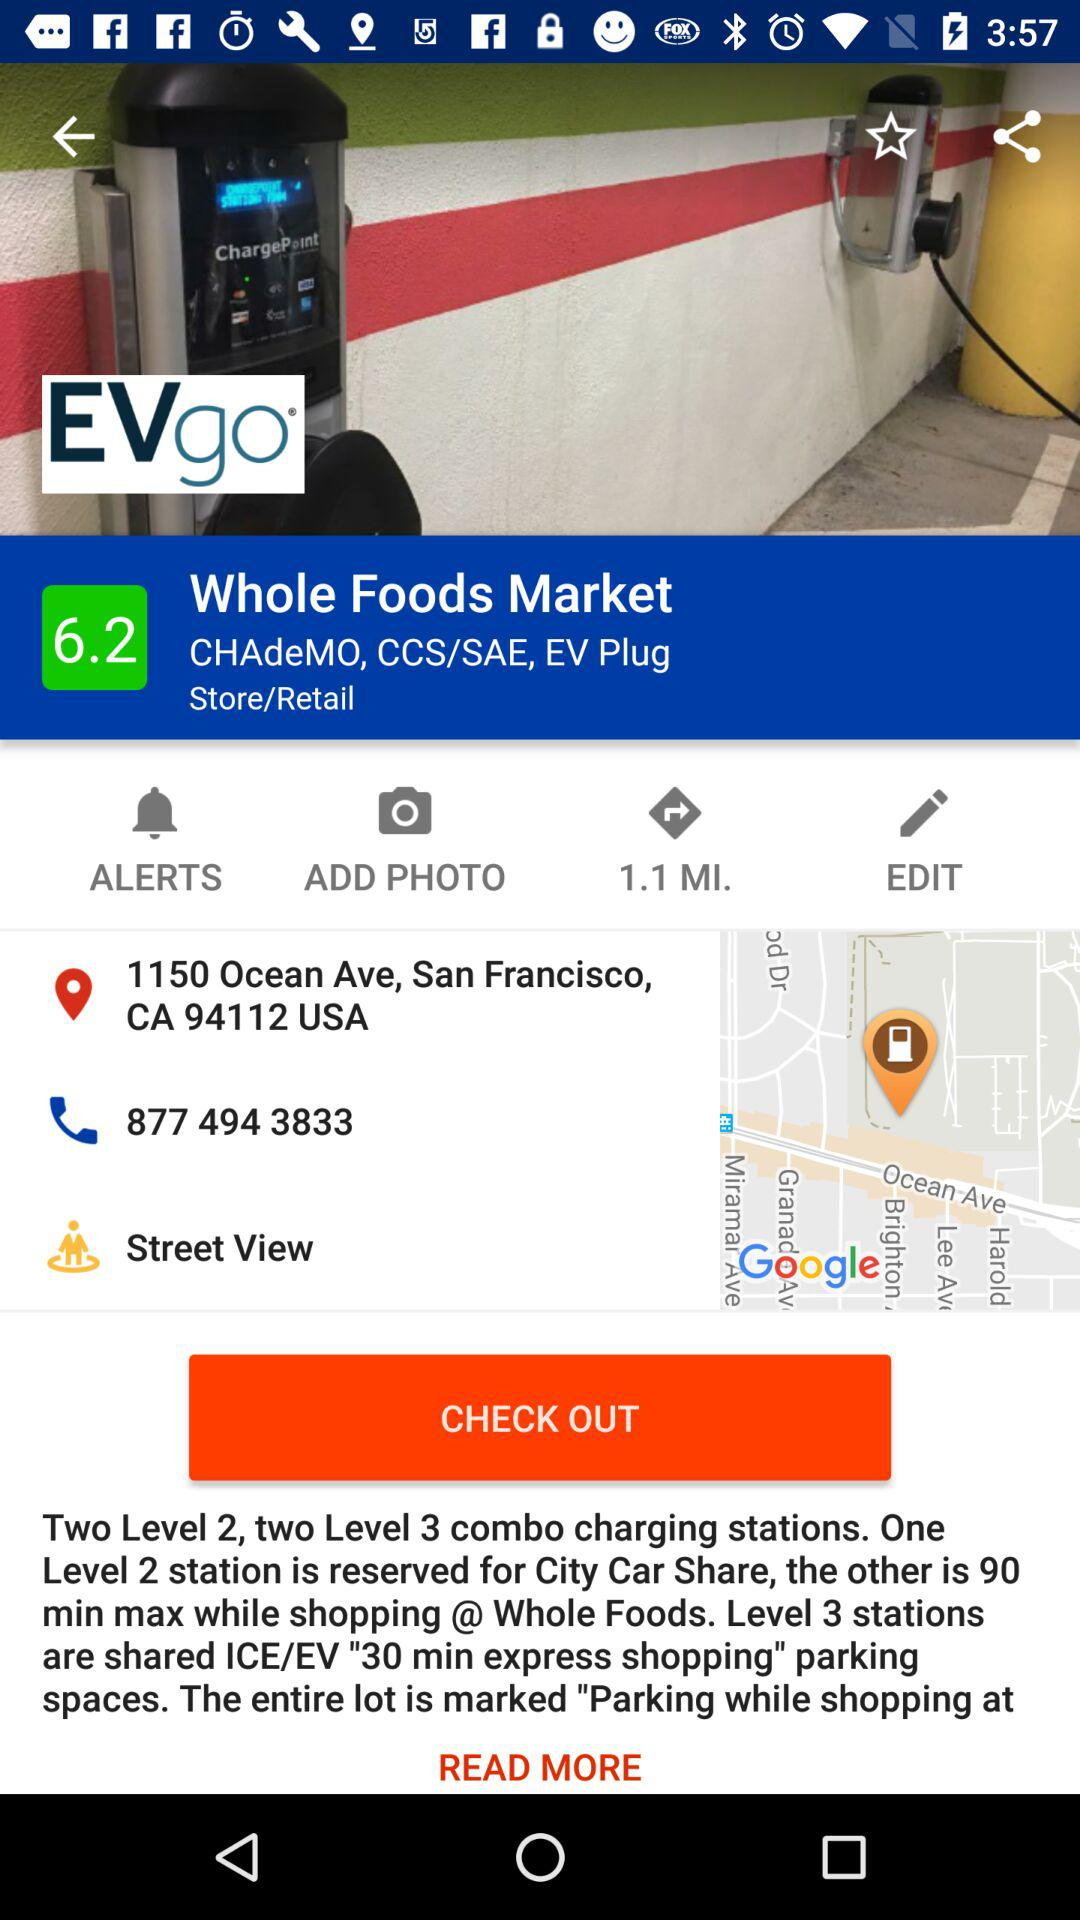What is the express shopping time for level 3? The time is 30 minutes. 